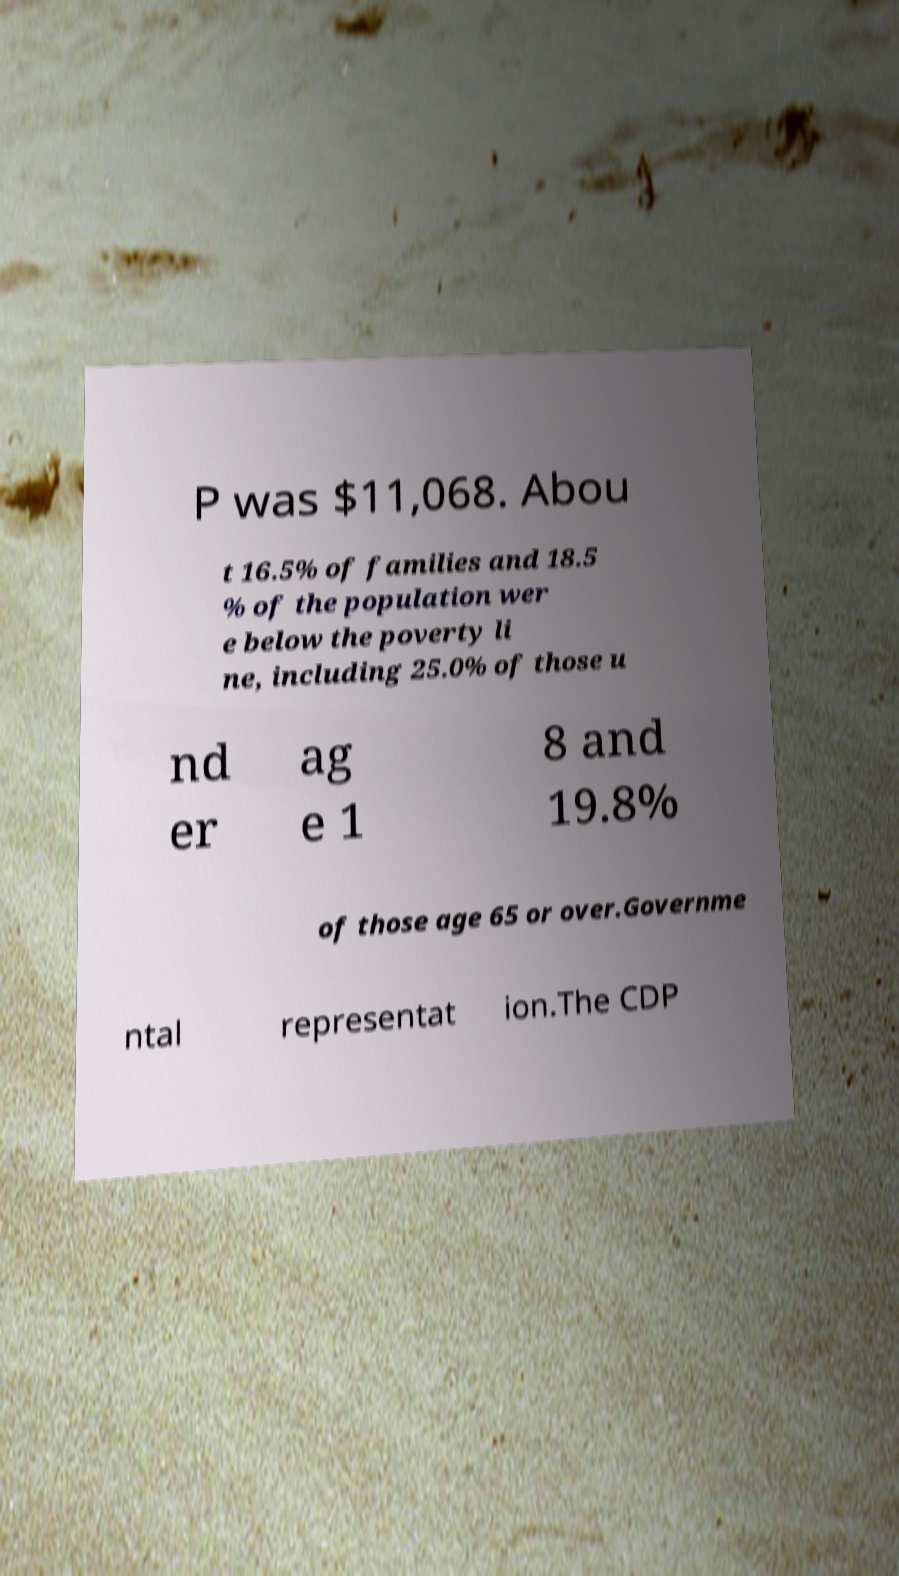Please identify and transcribe the text found in this image. P was $11,068. Abou t 16.5% of families and 18.5 % of the population wer e below the poverty li ne, including 25.0% of those u nd er ag e 1 8 and 19.8% of those age 65 or over.Governme ntal representat ion.The CDP 